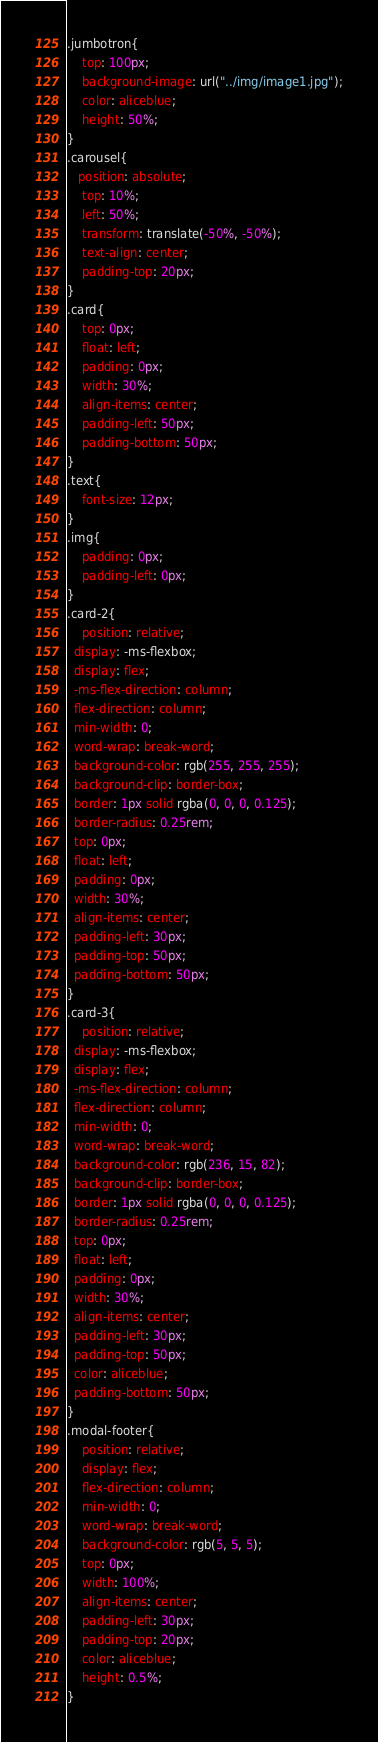Convert code to text. <code><loc_0><loc_0><loc_500><loc_500><_CSS_>.jumbotron{
    top: 100px;
    background-image: url("../img/image1.jpg");
    color: aliceblue;
    height: 50%;
}                   
.carousel{
   position: absolute;
    top: 10%;
    left: 50%;
    transform: translate(-50%, -50%);
    text-align: center;
    padding-top: 20px;
}
.card{
    top: 0px;
    float: left;
    padding: 0px;
    width: 30%;
    align-items: center;
    padding-left: 50px;
    padding-bottom: 50px;
}
.text{
    font-size: 12px;
}
.img{
    padding: 0px;
    padding-left: 0px;
}
.card-2{
    position: relative;
  display: -ms-flexbox;
  display: flex;
  -ms-flex-direction: column;
  flex-direction: column;
  min-width: 0;
  word-wrap: break-word;
  background-color: rgb(255, 255, 255);
  background-clip: border-box;
  border: 1px solid rgba(0, 0, 0, 0.125);
  border-radius: 0.25rem;
  top: 0px;
  float: left;
  padding: 0px;
  width: 30%;
  align-items: center;
  padding-left: 30px;
  padding-top: 50px;
  padding-bottom: 50px;
}
.card-3{
    position: relative;
  display: -ms-flexbox;
  display: flex;
  -ms-flex-direction: column;
  flex-direction: column;
  min-width: 0;
  word-wrap: break-word;
  background-color: rgb(236, 15, 82);
  background-clip: border-box;
  border: 1px solid rgba(0, 0, 0, 0.125);
  border-radius: 0.25rem;
  top: 0px;
  float: left;
  padding: 0px;
  width: 30%;
  align-items: center;
  padding-left: 30px;
  padding-top: 50px;
  color: aliceblue;
  padding-bottom: 50px;
}
.modal-footer{
    position: relative;
    display: flex;
    flex-direction: column;
    min-width: 0;
    word-wrap: break-word;
    background-color: rgb(5, 5, 5);
    top: 0px;
    width: 100%;
    align-items: center;
    padding-left: 30px;
    padding-top: 20px;
    color: aliceblue;
    height: 0.5%;
}</code> 